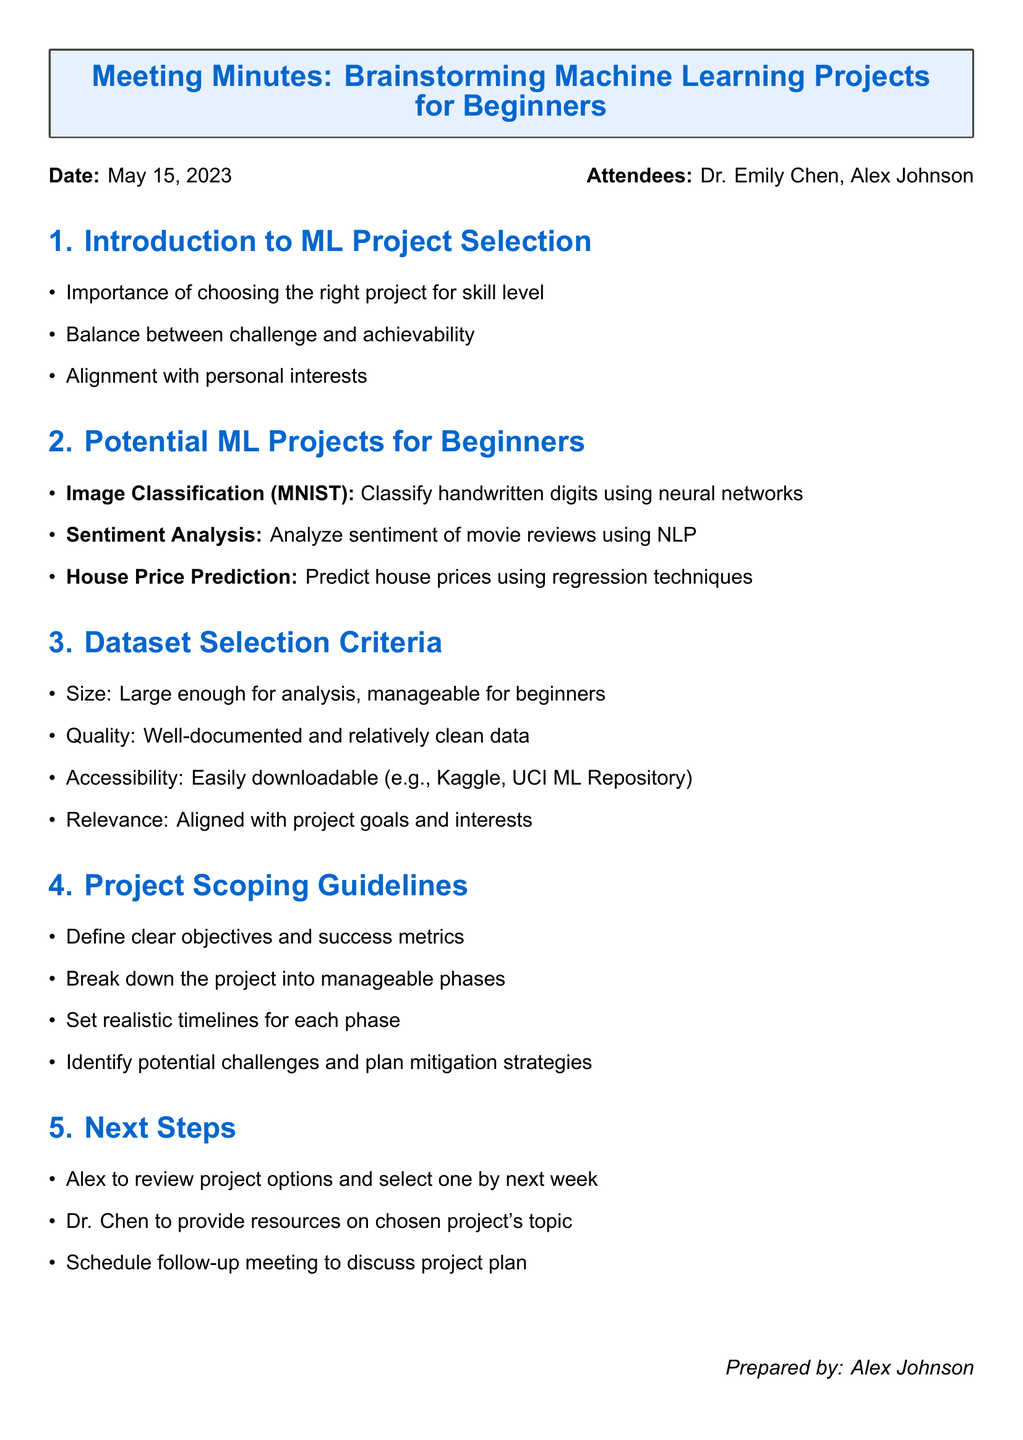what is the meeting title? The meeting title is stated at the beginning of the document, specifically labeled as "Meeting Minutes."
Answer: Brainstorming Machine Learning Projects for Beginners who are the attendees? The attendees are listed just below the date in the document.
Answer: Dr. Emily Chen, Alex Johnson what is the date of the meeting? The date of the meeting is provided right after the title, indicating when the meeting took place.
Answer: May 15, 2023 what is a potential ML project for beginners mentioned? The document lists several projects under the section on potential ML projects for beginners.
Answer: Image Classification with MNIST Dataset what is a criterion for dataset selection? The document details various criteria for dataset selection, focusing on key factors to consider.
Answer: Size: Large enough for meaningful analysis, but manageable for beginners what is one guideline for project scoping? The project scoping guidelines are outlined in a bullet list; one of these guidelines addresses a key aspect of project management.
Answer: Define clear objectives and success metrics who will provide resources on the chosen project's topic? The next steps section outlines responsibilities assigned to attendees following the meeting.
Answer: Dr. Chen by when does Alex need to select a project? The document specifies a timeline for actions following the meeting to keep the project moving.
Answer: Next week 